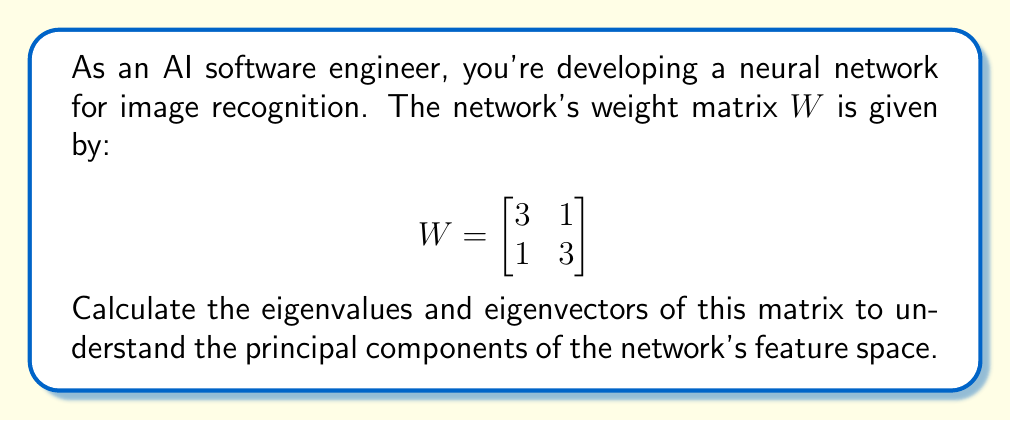Show me your answer to this math problem. To find the eigenvalues and eigenvectors of matrix $W$, we follow these steps:

1) First, we calculate the eigenvalues by solving the characteristic equation:
   $det(W - \lambda I) = 0$

   $$\begin{vmatrix}
   3-\lambda & 1 \\
   1 & 3-\lambda
   \end{vmatrix} = 0$$

2) Expand the determinant:
   $(3-\lambda)(3-\lambda) - 1 = 0$
   $(3-\lambda)^2 - 1 = 0$
   $9 - 6\lambda + \lambda^2 - 1 = 0$
   $\lambda^2 - 6\lambda + 8 = 0$

3) Solve the quadratic equation:
   $(\lambda - 4)(\lambda - 2) = 0$
   $\lambda = 4$ or $\lambda = 2$

4) For each eigenvalue, find the corresponding eigenvector by solving $(W - \lambda I)v = 0$:

   For $\lambda_1 = 4$:
   $$\begin{bmatrix}
   -1 & 1 \\
   1 & -1
   \end{bmatrix}\begin{bmatrix}
   v_1 \\
   v_2
   \end{bmatrix} = \begin{bmatrix}
   0 \\
   0
   \end{bmatrix}$$

   This gives us: $v_1 = v_2$. We can choose $v_1 = \begin{bmatrix} 1 \\ 1 \end{bmatrix}$.

   For $\lambda_2 = 2$:
   $$\begin{bmatrix}
   1 & 1 \\
   1 & 1
   \end{bmatrix}\begin{bmatrix}
   v_1 \\
   v_2
   \end{bmatrix} = \begin{bmatrix}
   0 \\
   0
   \end{bmatrix}$$

   This gives us: $v_1 = -v_2$. We can choose $v_2 = \begin{bmatrix} 1 \\ -1 \end{bmatrix}$.
Answer: Eigenvalues: $\lambda_1 = 4$, $\lambda_2 = 2$
Eigenvectors: $v_1 = \begin{bmatrix} 1 \\ 1 \end{bmatrix}$, $v_2 = \begin{bmatrix} 1 \\ -1 \end{bmatrix}$ 